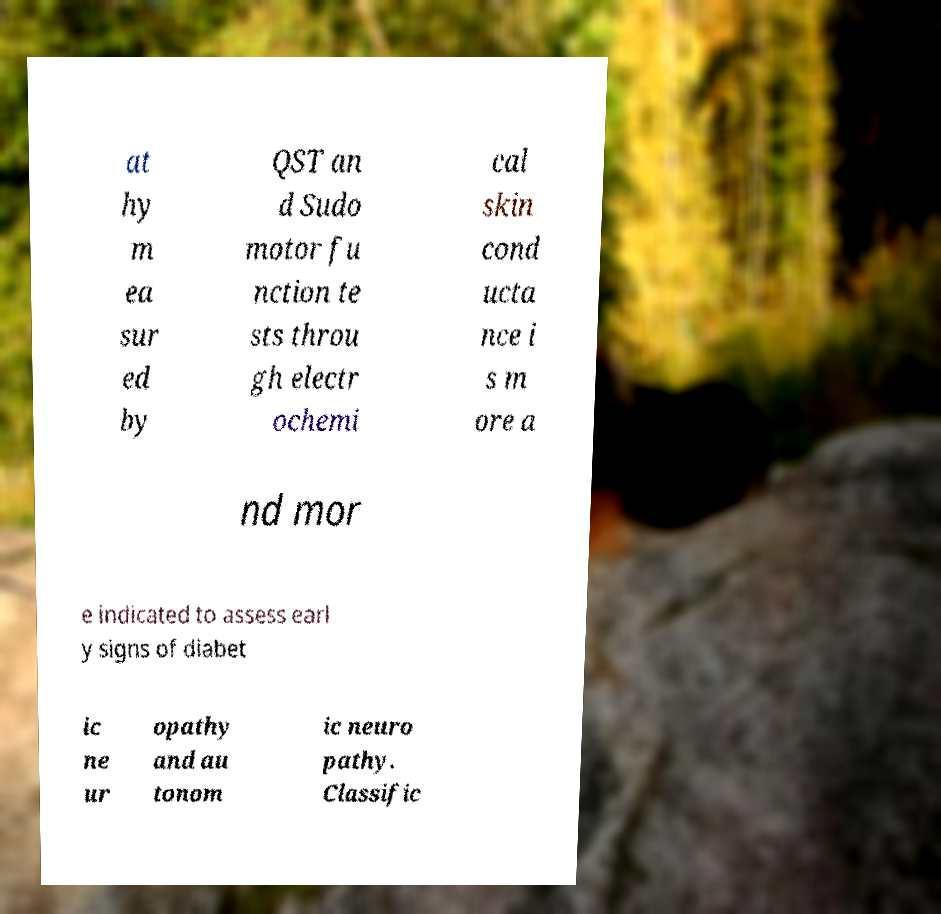Please identify and transcribe the text found in this image. at hy m ea sur ed by QST an d Sudo motor fu nction te sts throu gh electr ochemi cal skin cond ucta nce i s m ore a nd mor e indicated to assess earl y signs of diabet ic ne ur opathy and au tonom ic neuro pathy. Classific 